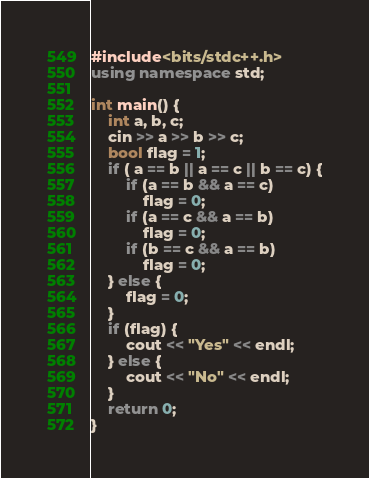<code> <loc_0><loc_0><loc_500><loc_500><_C++_>#include<bits/stdc++.h>
using namespace std;

int main() {
	int a, b, c;
	cin >> a >> b >> c;
	bool flag = 1;
	if ( a == b || a == c || b == c) {
		if (a == b && a == c)
			flag = 0;
		if (a == c && a == b)
			flag = 0;
		if (b == c && a == b)
			flag = 0;	
	} else {
		flag = 0;
	}
	if (flag) {
		cout << "Yes" << endl;
	} else {
		cout << "No" << endl;
	}
	return 0;
}</code> 